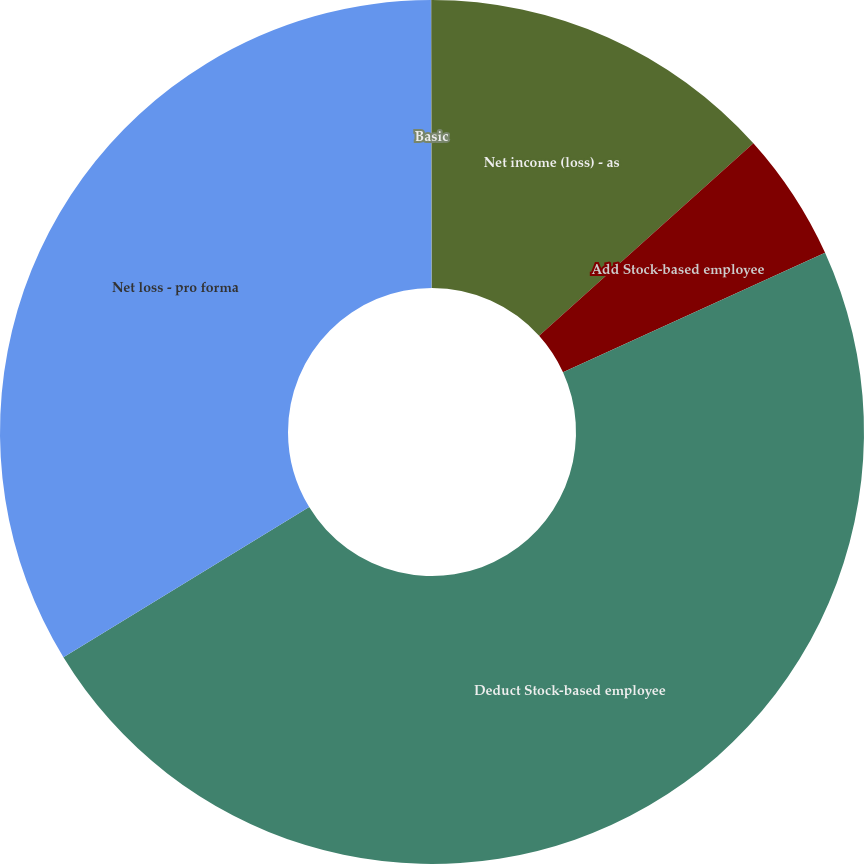<chart> <loc_0><loc_0><loc_500><loc_500><pie_chart><fcel>Net income (loss) - as<fcel>Add Stock-based employee<fcel>Deduct Stock-based employee<fcel>Net loss - pro forma<fcel>Basic<nl><fcel>13.35%<fcel>4.84%<fcel>48.07%<fcel>33.69%<fcel>0.04%<nl></chart> 